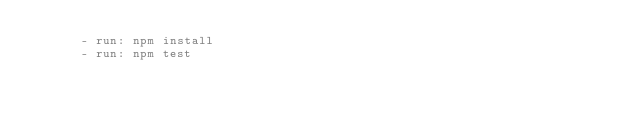<code> <loc_0><loc_0><loc_500><loc_500><_YAML_>      - run: npm install
      - run: npm test
</code> 